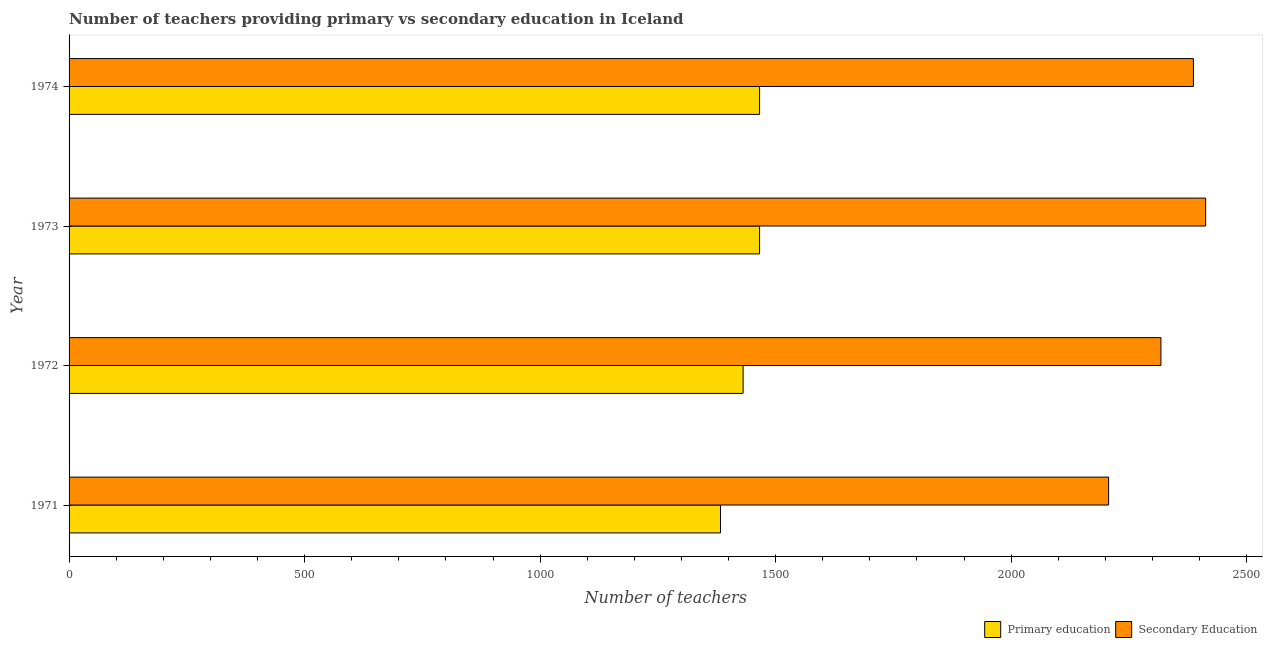How many different coloured bars are there?
Your response must be concise. 2. How many bars are there on the 1st tick from the top?
Make the answer very short. 2. How many bars are there on the 3rd tick from the bottom?
Make the answer very short. 2. In how many cases, is the number of bars for a given year not equal to the number of legend labels?
Offer a terse response. 0. What is the number of primary teachers in 1974?
Make the answer very short. 1466. Across all years, what is the maximum number of secondary teachers?
Provide a succinct answer. 2413. Across all years, what is the minimum number of secondary teachers?
Provide a succinct answer. 2207. In which year was the number of secondary teachers minimum?
Offer a terse response. 1971. What is the total number of primary teachers in the graph?
Offer a terse response. 5746. What is the difference between the number of secondary teachers in 1972 and that in 1973?
Provide a succinct answer. -95. What is the difference between the number of primary teachers in 1973 and the number of secondary teachers in 1972?
Keep it short and to the point. -852. What is the average number of secondary teachers per year?
Make the answer very short. 2331.25. In the year 1972, what is the difference between the number of primary teachers and number of secondary teachers?
Offer a terse response. -887. In how many years, is the number of primary teachers greater than 800 ?
Provide a succinct answer. 4. What is the ratio of the number of secondary teachers in 1972 to that in 1974?
Ensure brevity in your answer.  0.97. Is the number of primary teachers in 1972 less than that in 1973?
Give a very brief answer. Yes. What is the difference between the highest and the lowest number of primary teachers?
Provide a succinct answer. 83. In how many years, is the number of secondary teachers greater than the average number of secondary teachers taken over all years?
Your answer should be compact. 2. Is the sum of the number of secondary teachers in 1971 and 1974 greater than the maximum number of primary teachers across all years?
Offer a terse response. Yes. What does the 2nd bar from the top in 1972 represents?
Your answer should be compact. Primary education. What does the 1st bar from the bottom in 1971 represents?
Provide a short and direct response. Primary education. How many years are there in the graph?
Your answer should be compact. 4. What is the difference between two consecutive major ticks on the X-axis?
Provide a short and direct response. 500. Are the values on the major ticks of X-axis written in scientific E-notation?
Your response must be concise. No. Does the graph contain grids?
Provide a short and direct response. No. How are the legend labels stacked?
Offer a very short reply. Horizontal. What is the title of the graph?
Your answer should be compact. Number of teachers providing primary vs secondary education in Iceland. What is the label or title of the X-axis?
Your response must be concise. Number of teachers. What is the Number of teachers in Primary education in 1971?
Make the answer very short. 1383. What is the Number of teachers of Secondary Education in 1971?
Ensure brevity in your answer.  2207. What is the Number of teachers of Primary education in 1972?
Keep it short and to the point. 1431. What is the Number of teachers of Secondary Education in 1972?
Offer a very short reply. 2318. What is the Number of teachers of Primary education in 1973?
Your response must be concise. 1466. What is the Number of teachers in Secondary Education in 1973?
Offer a very short reply. 2413. What is the Number of teachers in Primary education in 1974?
Your answer should be very brief. 1466. What is the Number of teachers in Secondary Education in 1974?
Make the answer very short. 2387. Across all years, what is the maximum Number of teachers in Primary education?
Provide a succinct answer. 1466. Across all years, what is the maximum Number of teachers in Secondary Education?
Your response must be concise. 2413. Across all years, what is the minimum Number of teachers in Primary education?
Offer a terse response. 1383. Across all years, what is the minimum Number of teachers of Secondary Education?
Make the answer very short. 2207. What is the total Number of teachers in Primary education in the graph?
Your answer should be very brief. 5746. What is the total Number of teachers in Secondary Education in the graph?
Keep it short and to the point. 9325. What is the difference between the Number of teachers in Primary education in 1971 and that in 1972?
Your response must be concise. -48. What is the difference between the Number of teachers in Secondary Education in 1971 and that in 1972?
Your answer should be compact. -111. What is the difference between the Number of teachers of Primary education in 1971 and that in 1973?
Offer a terse response. -83. What is the difference between the Number of teachers of Secondary Education in 1971 and that in 1973?
Keep it short and to the point. -206. What is the difference between the Number of teachers in Primary education in 1971 and that in 1974?
Your response must be concise. -83. What is the difference between the Number of teachers of Secondary Education in 1971 and that in 1974?
Keep it short and to the point. -180. What is the difference between the Number of teachers in Primary education in 1972 and that in 1973?
Provide a short and direct response. -35. What is the difference between the Number of teachers of Secondary Education in 1972 and that in 1973?
Offer a very short reply. -95. What is the difference between the Number of teachers in Primary education in 1972 and that in 1974?
Offer a very short reply. -35. What is the difference between the Number of teachers of Secondary Education in 1972 and that in 1974?
Provide a succinct answer. -69. What is the difference between the Number of teachers of Primary education in 1973 and that in 1974?
Your answer should be very brief. 0. What is the difference between the Number of teachers in Primary education in 1971 and the Number of teachers in Secondary Education in 1972?
Your answer should be very brief. -935. What is the difference between the Number of teachers of Primary education in 1971 and the Number of teachers of Secondary Education in 1973?
Offer a terse response. -1030. What is the difference between the Number of teachers in Primary education in 1971 and the Number of teachers in Secondary Education in 1974?
Provide a short and direct response. -1004. What is the difference between the Number of teachers of Primary education in 1972 and the Number of teachers of Secondary Education in 1973?
Give a very brief answer. -982. What is the difference between the Number of teachers of Primary education in 1972 and the Number of teachers of Secondary Education in 1974?
Your response must be concise. -956. What is the difference between the Number of teachers in Primary education in 1973 and the Number of teachers in Secondary Education in 1974?
Make the answer very short. -921. What is the average Number of teachers in Primary education per year?
Give a very brief answer. 1436.5. What is the average Number of teachers in Secondary Education per year?
Ensure brevity in your answer.  2331.25. In the year 1971, what is the difference between the Number of teachers in Primary education and Number of teachers in Secondary Education?
Ensure brevity in your answer.  -824. In the year 1972, what is the difference between the Number of teachers of Primary education and Number of teachers of Secondary Education?
Ensure brevity in your answer.  -887. In the year 1973, what is the difference between the Number of teachers in Primary education and Number of teachers in Secondary Education?
Give a very brief answer. -947. In the year 1974, what is the difference between the Number of teachers of Primary education and Number of teachers of Secondary Education?
Your answer should be very brief. -921. What is the ratio of the Number of teachers of Primary education in 1971 to that in 1972?
Your answer should be very brief. 0.97. What is the ratio of the Number of teachers of Secondary Education in 1971 to that in 1972?
Offer a terse response. 0.95. What is the ratio of the Number of teachers of Primary education in 1971 to that in 1973?
Give a very brief answer. 0.94. What is the ratio of the Number of teachers of Secondary Education in 1971 to that in 1973?
Offer a terse response. 0.91. What is the ratio of the Number of teachers of Primary education in 1971 to that in 1974?
Provide a short and direct response. 0.94. What is the ratio of the Number of teachers in Secondary Education in 1971 to that in 1974?
Make the answer very short. 0.92. What is the ratio of the Number of teachers in Primary education in 1972 to that in 1973?
Your answer should be compact. 0.98. What is the ratio of the Number of teachers in Secondary Education in 1972 to that in 1973?
Ensure brevity in your answer.  0.96. What is the ratio of the Number of teachers of Primary education in 1972 to that in 1974?
Offer a terse response. 0.98. What is the ratio of the Number of teachers of Secondary Education in 1972 to that in 1974?
Your response must be concise. 0.97. What is the ratio of the Number of teachers in Primary education in 1973 to that in 1974?
Your answer should be compact. 1. What is the ratio of the Number of teachers in Secondary Education in 1973 to that in 1974?
Offer a very short reply. 1.01. What is the difference between the highest and the second highest Number of teachers in Primary education?
Provide a short and direct response. 0. What is the difference between the highest and the second highest Number of teachers in Secondary Education?
Keep it short and to the point. 26. What is the difference between the highest and the lowest Number of teachers in Secondary Education?
Your response must be concise. 206. 